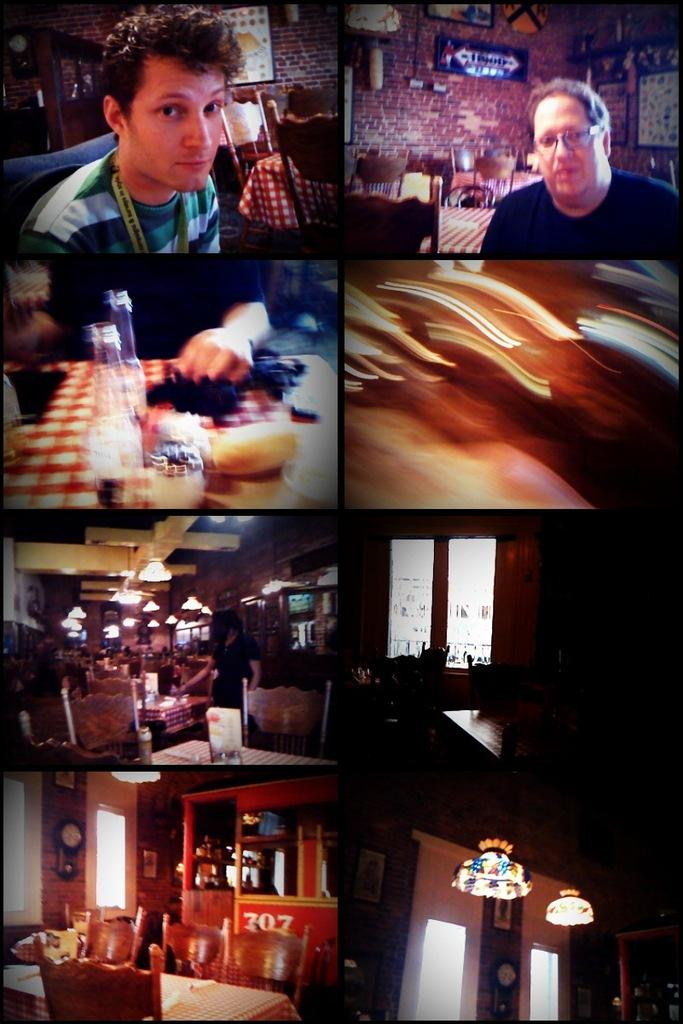How many people are in the image? There are persons in the image, but the exact number is not specified. What type of furniture is present in the image? There are tables and chairs in the image. What type of lighting is present in the image? There are lights in the image. What type of window is present in the image? There are glass windows in the image. What type of wall is present in the image? There is a wall in the image. What type of timekeeping device is present in the image? There is a clock in the image. What type of scheduling device is present in the image? There is a calendar in the image. What type of decorative items are present on the wall in the image? There are photo frames on the wall in the image. What is the tendency of the quince to grow in the image? There is no quince present in the image, so its tendency to grow cannot be determined. What type of humor is depicted in the image? There is no humor depicted in the image; it is a scene with people, furniture, and decorative items. 